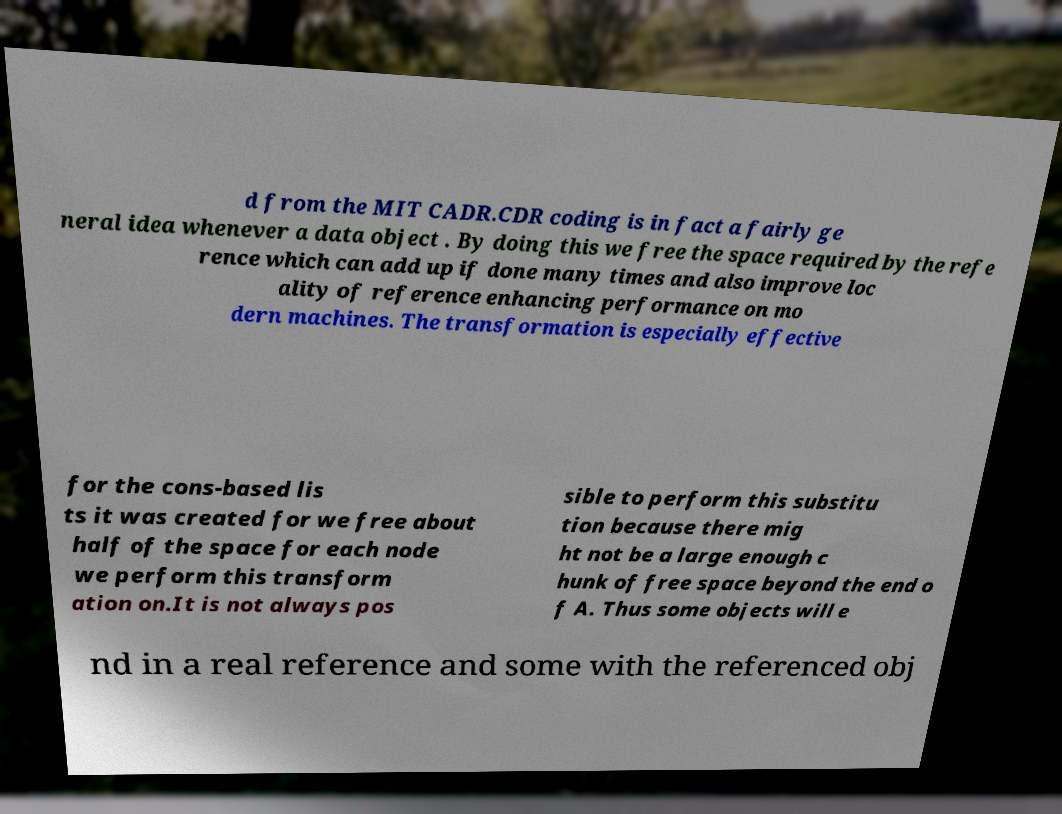What messages or text are displayed in this image? I need them in a readable, typed format. d from the MIT CADR.CDR coding is in fact a fairly ge neral idea whenever a data object . By doing this we free the space required by the refe rence which can add up if done many times and also improve loc ality of reference enhancing performance on mo dern machines. The transformation is especially effective for the cons-based lis ts it was created for we free about half of the space for each node we perform this transform ation on.It is not always pos sible to perform this substitu tion because there mig ht not be a large enough c hunk of free space beyond the end o f A. Thus some objects will e nd in a real reference and some with the referenced obj 